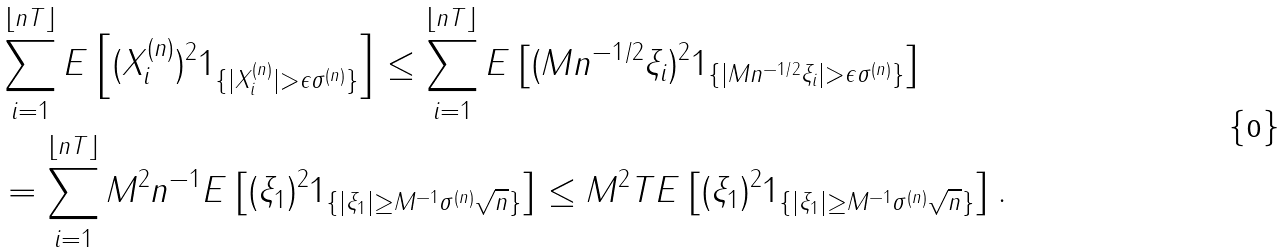<formula> <loc_0><loc_0><loc_500><loc_500>& \sum _ { i = 1 } ^ { \lfloor n T \rfloor } E \left [ ( X ^ { ( n ) } _ { i } ) ^ { 2 } 1 _ { \{ | X ^ { ( n ) } _ { i } | > \epsilon \sigma ^ { ( n ) } \} } \right ] \leq \sum _ { i = 1 } ^ { \lfloor n T \rfloor } E \left [ ( M n ^ { - 1 / 2 } \xi _ { i } ) ^ { 2 } 1 _ { \{ | M n ^ { - 1 / 2 } \xi _ { i } | > \epsilon \sigma ^ { ( n ) } \} } \right ] \\ & = \sum _ { i = 1 } ^ { \lfloor n T \rfloor } M ^ { 2 } n ^ { - 1 } E \left [ ( \xi _ { 1 } ) ^ { 2 } 1 _ { \{ | \xi _ { 1 } | \geq M ^ { - 1 } \sigma ^ { ( n ) } \sqrt { n } \} } \right ] \leq M ^ { 2 } T E \left [ ( \xi _ { 1 } ) ^ { 2 } 1 _ { \{ | \xi _ { 1 } | \geq M ^ { - 1 } \sigma ^ { ( n ) } \sqrt { n } \} } \right ] .</formula> 